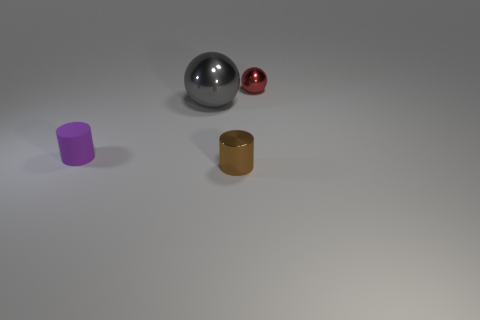Add 3 red things. How many objects exist? 7 Subtract all purple metallic spheres. Subtract all small brown metallic things. How many objects are left? 3 Add 3 red objects. How many red objects are left? 4 Add 4 cyan matte things. How many cyan matte things exist? 4 Subtract 0 purple balls. How many objects are left? 4 